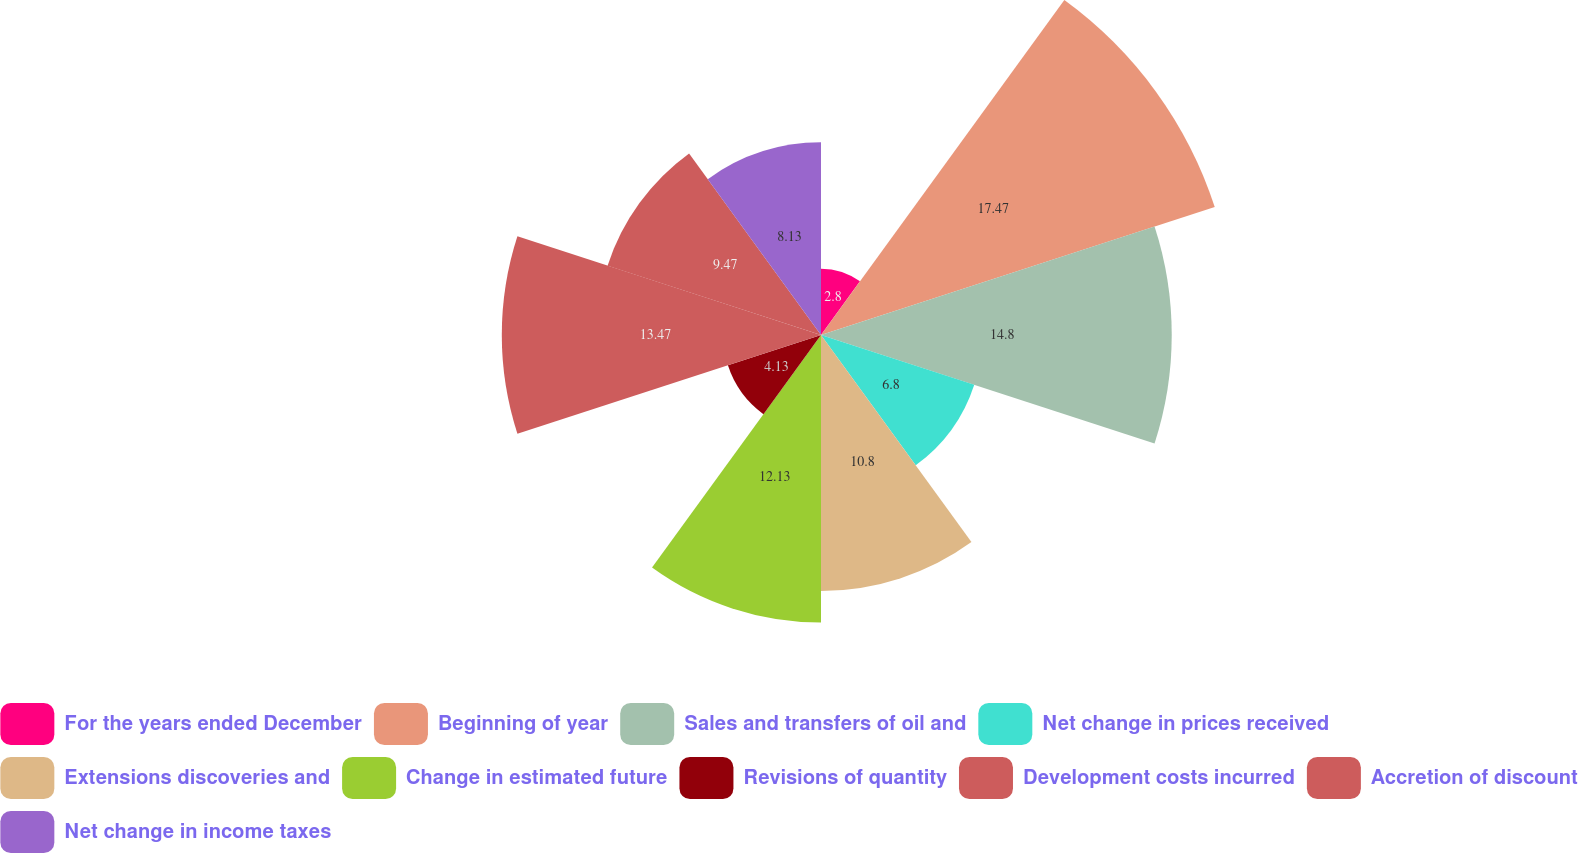<chart> <loc_0><loc_0><loc_500><loc_500><pie_chart><fcel>For the years ended December<fcel>Beginning of year<fcel>Sales and transfers of oil and<fcel>Net change in prices received<fcel>Extensions discoveries and<fcel>Change in estimated future<fcel>Revisions of quantity<fcel>Development costs incurred<fcel>Accretion of discount<fcel>Net change in income taxes<nl><fcel>2.8%<fcel>17.47%<fcel>14.8%<fcel>6.8%<fcel>10.8%<fcel>12.13%<fcel>4.13%<fcel>13.47%<fcel>9.47%<fcel>8.13%<nl></chart> 